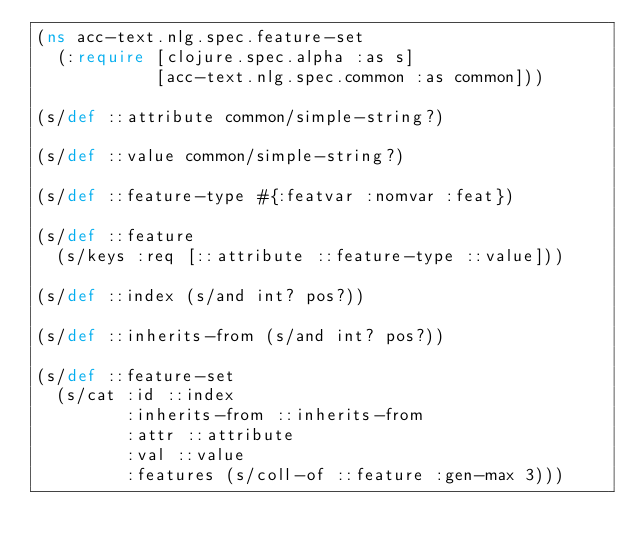<code> <loc_0><loc_0><loc_500><loc_500><_Clojure_>(ns acc-text.nlg.spec.feature-set
  (:require [clojure.spec.alpha :as s]
            [acc-text.nlg.spec.common :as common]))

(s/def ::attribute common/simple-string?)

(s/def ::value common/simple-string?)

(s/def ::feature-type #{:featvar :nomvar :feat})

(s/def ::feature
  (s/keys :req [::attribute ::feature-type ::value]))

(s/def ::index (s/and int? pos?))

(s/def ::inherits-from (s/and int? pos?))

(s/def ::feature-set
  (s/cat :id ::index
         :inherits-from ::inherits-from
         :attr ::attribute
         :val ::value
         :features (s/coll-of ::feature :gen-max 3)))
</code> 